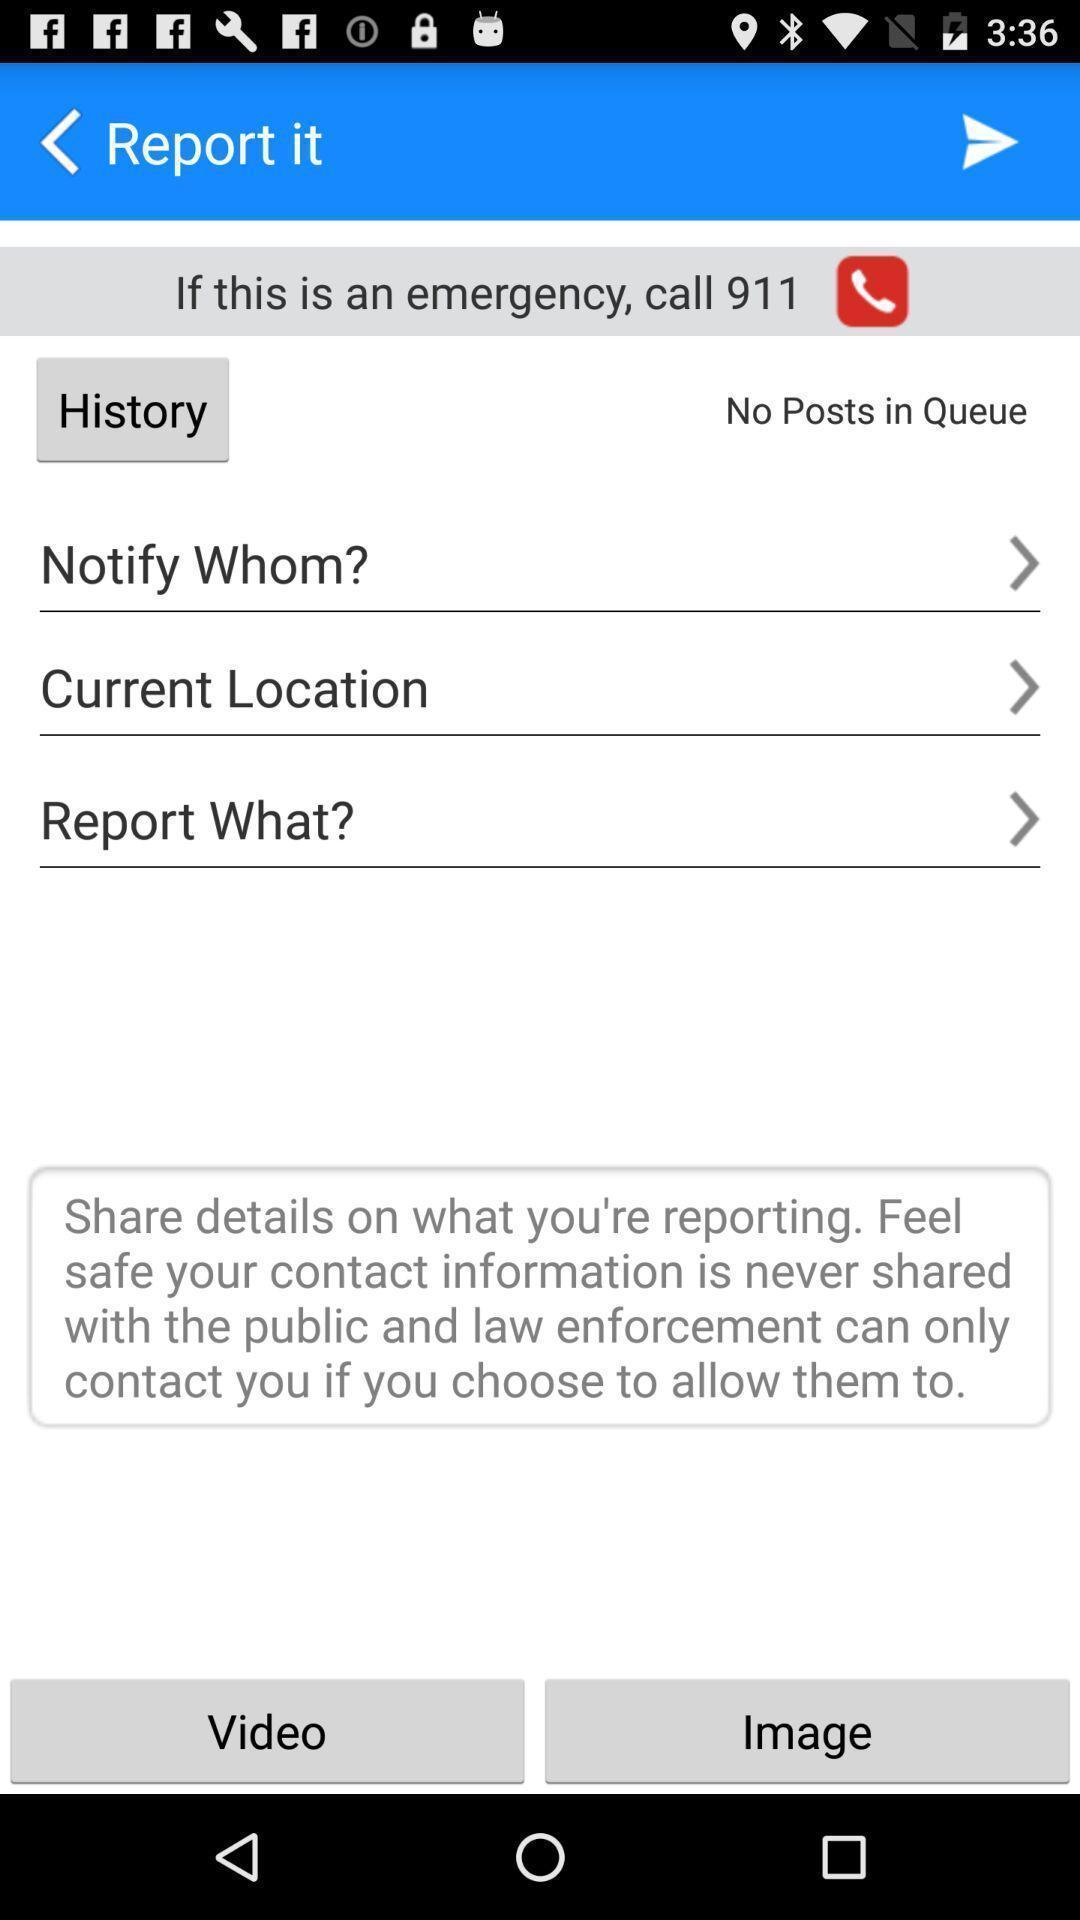Describe this image in words. Screen displaying the report page. 